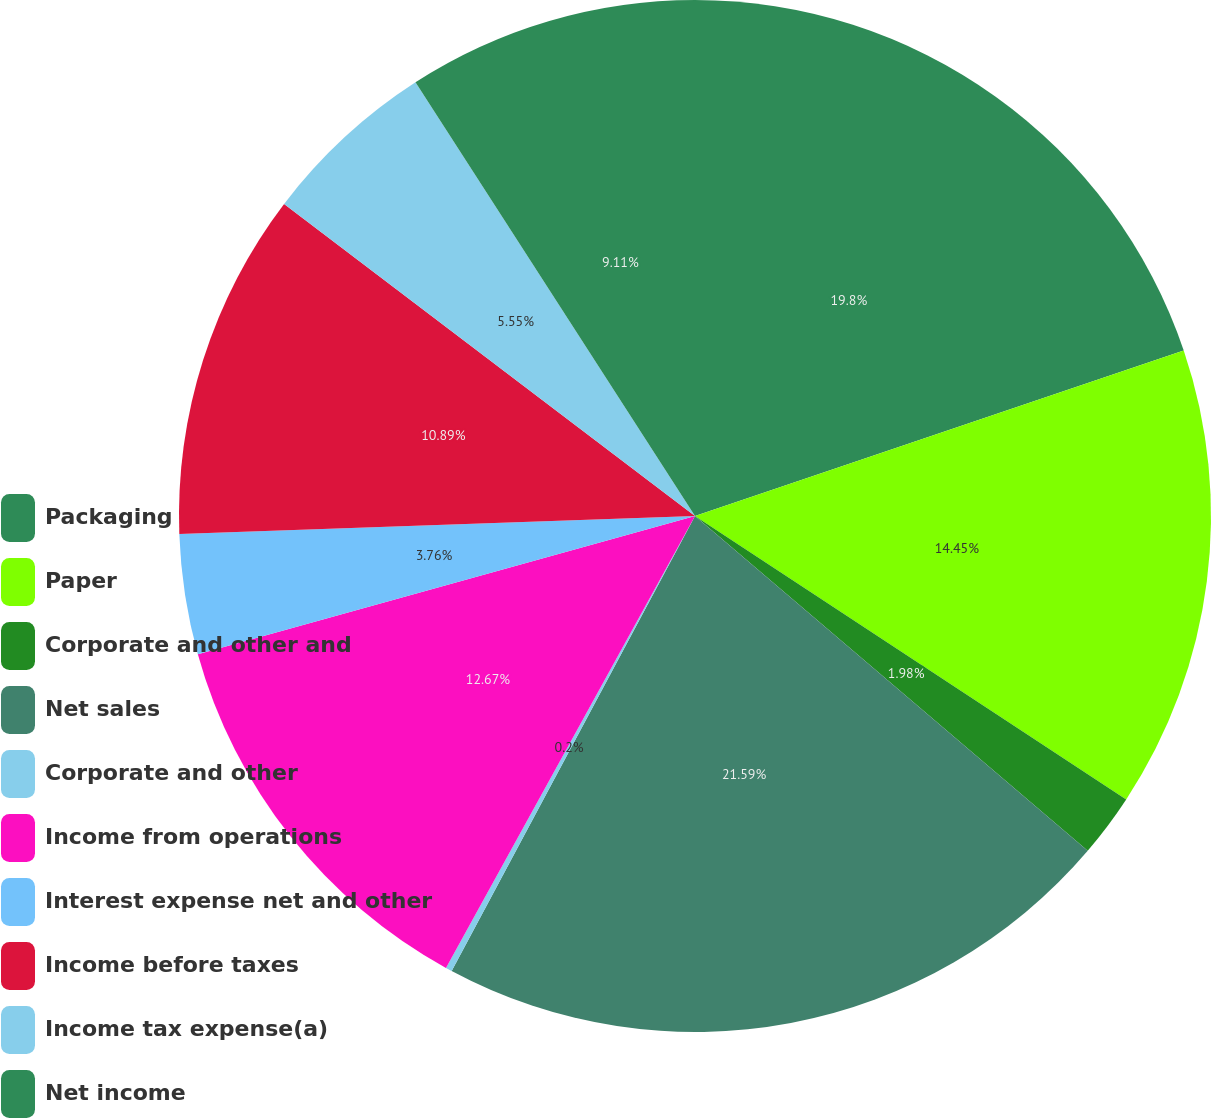Convert chart. <chart><loc_0><loc_0><loc_500><loc_500><pie_chart><fcel>Packaging<fcel>Paper<fcel>Corporate and other and<fcel>Net sales<fcel>Corporate and other<fcel>Income from operations<fcel>Interest expense net and other<fcel>Income before taxes<fcel>Income tax expense(a)<fcel>Net income<nl><fcel>19.8%<fcel>14.45%<fcel>1.98%<fcel>21.58%<fcel>0.2%<fcel>12.67%<fcel>3.76%<fcel>10.89%<fcel>5.55%<fcel>9.11%<nl></chart> 